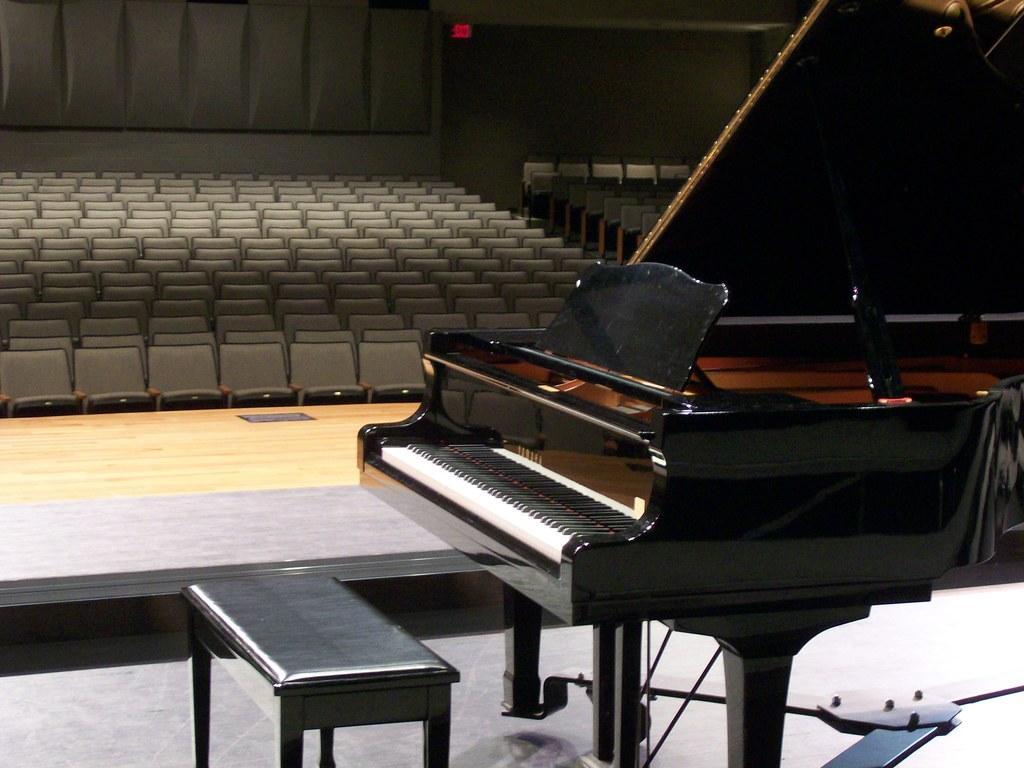Could you give a brief overview of what you see in this image? This is an auditorium. There is a piano on the stage in front of it there is a table. There are so many chairs for the audience. In the background there is a red caution light. The wall is having one design. The floor is wooden furnished. 